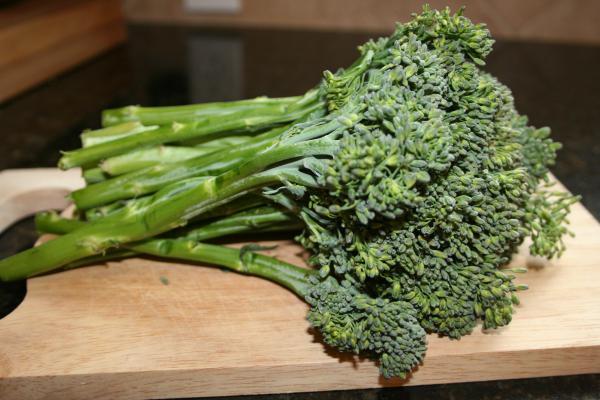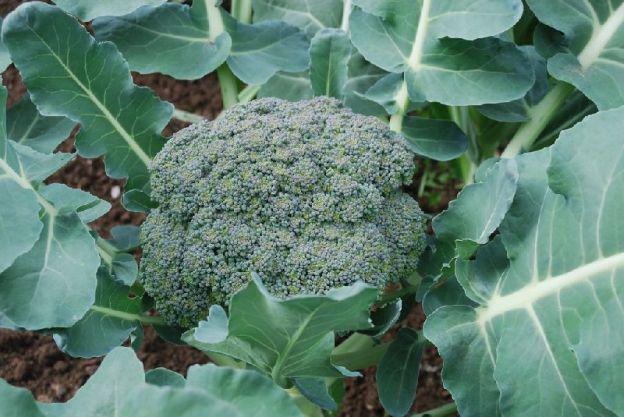The first image is the image on the left, the second image is the image on the right. Considering the images on both sides, is "Broccoli is shown in both images, but in one it is a plant in the garden and in the other, it is cleaned for eating or cooking." valid? Answer yes or no. Yes. The first image is the image on the left, the second image is the image on the right. For the images shown, is this caption "An image shows broccoli growing in soil, with leaves surrounding the florets." true? Answer yes or no. Yes. 